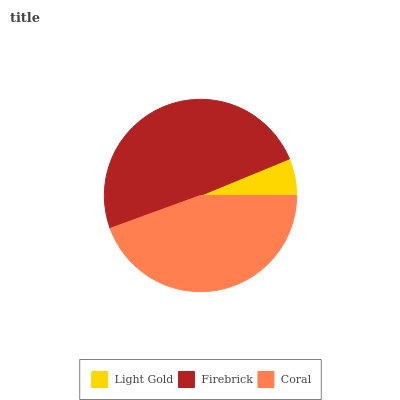Is Light Gold the minimum?
Answer yes or no. Yes. Is Firebrick the maximum?
Answer yes or no. Yes. Is Coral the minimum?
Answer yes or no. No. Is Coral the maximum?
Answer yes or no. No. Is Firebrick greater than Coral?
Answer yes or no. Yes. Is Coral less than Firebrick?
Answer yes or no. Yes. Is Coral greater than Firebrick?
Answer yes or no. No. Is Firebrick less than Coral?
Answer yes or no. No. Is Coral the high median?
Answer yes or no. Yes. Is Coral the low median?
Answer yes or no. Yes. Is Light Gold the high median?
Answer yes or no. No. Is Light Gold the low median?
Answer yes or no. No. 